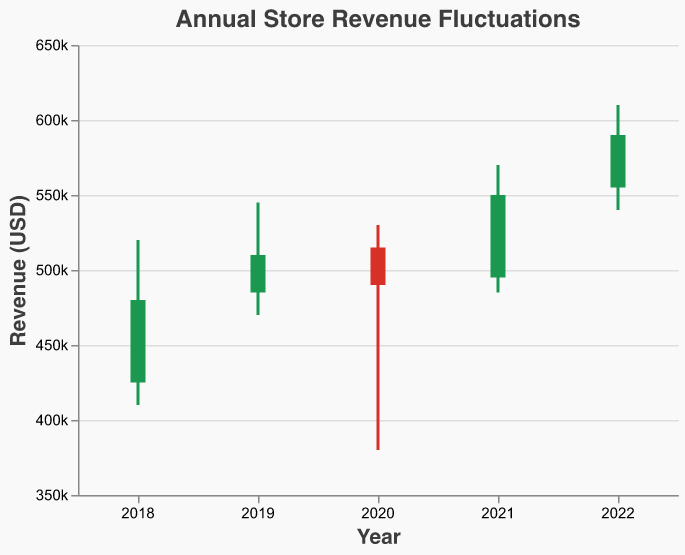What is the title of the chart? The title of the chart is displayed at the top of the figure.
Answer: Annual Store Revenue Fluctuations What is the highest revenue recorded in 2020? By looking at the bar representing the year 2020 and the endpoint of the highest point, we can see the highest revenue recorded.
Answer: 530000 In which year did the store open with the lowest revenue? Compare the opening revenues for each year and identify the lowest one.
Answer: 2018 Between which years did the store see the largest increase in opening revenue? Calculate the year-to-year differences in opening revenue and identify the largest increase. (2019-2018), (2020-2019), (2021-2020), and (2022-2021) differences are 60000, 30000, (20000) and 60000 respectively
Answer: 2021 to 2022 Which year had the smallest difference between the highest and lowest revenue points within the year? Subtract the lowest revenue from the highest revenue for each year and identify the smallest difference. Differences: 2018=110000, 2019=75000, 2020=150000, 2021=85000, 2022=70000
Answer: 2022 What was the revenue at the closing of 2019? Look at the bar representing the year 2019 and identify the closing point
Answer: 510000 Did the revenue close higher than it opened in 2020? Compare the opening and closing values for 2020.
Answer: No Which year shows the highest closing revenue? Compare the closing points for all the years and identify the highest closing revenue.
Answer: 2022 What is the difference between the closing revenue of 2021 and the closing revenue of 2020? Subtract the closing revenue of 2020 from the closing revenue of 2021. The closing revenue of 2021 is 550000, and the closing revenue of 2020 is 490000. 550000 - 490000 = 60000
Answer: 60000 Which years had an increase in closing revenue compared to the previous year? Compare the closing revenues of each year with the previous year's closing revenues and list those with an increase.
Answer: 2018 → 2019, 2020 → 2021, 2021 → 2022 